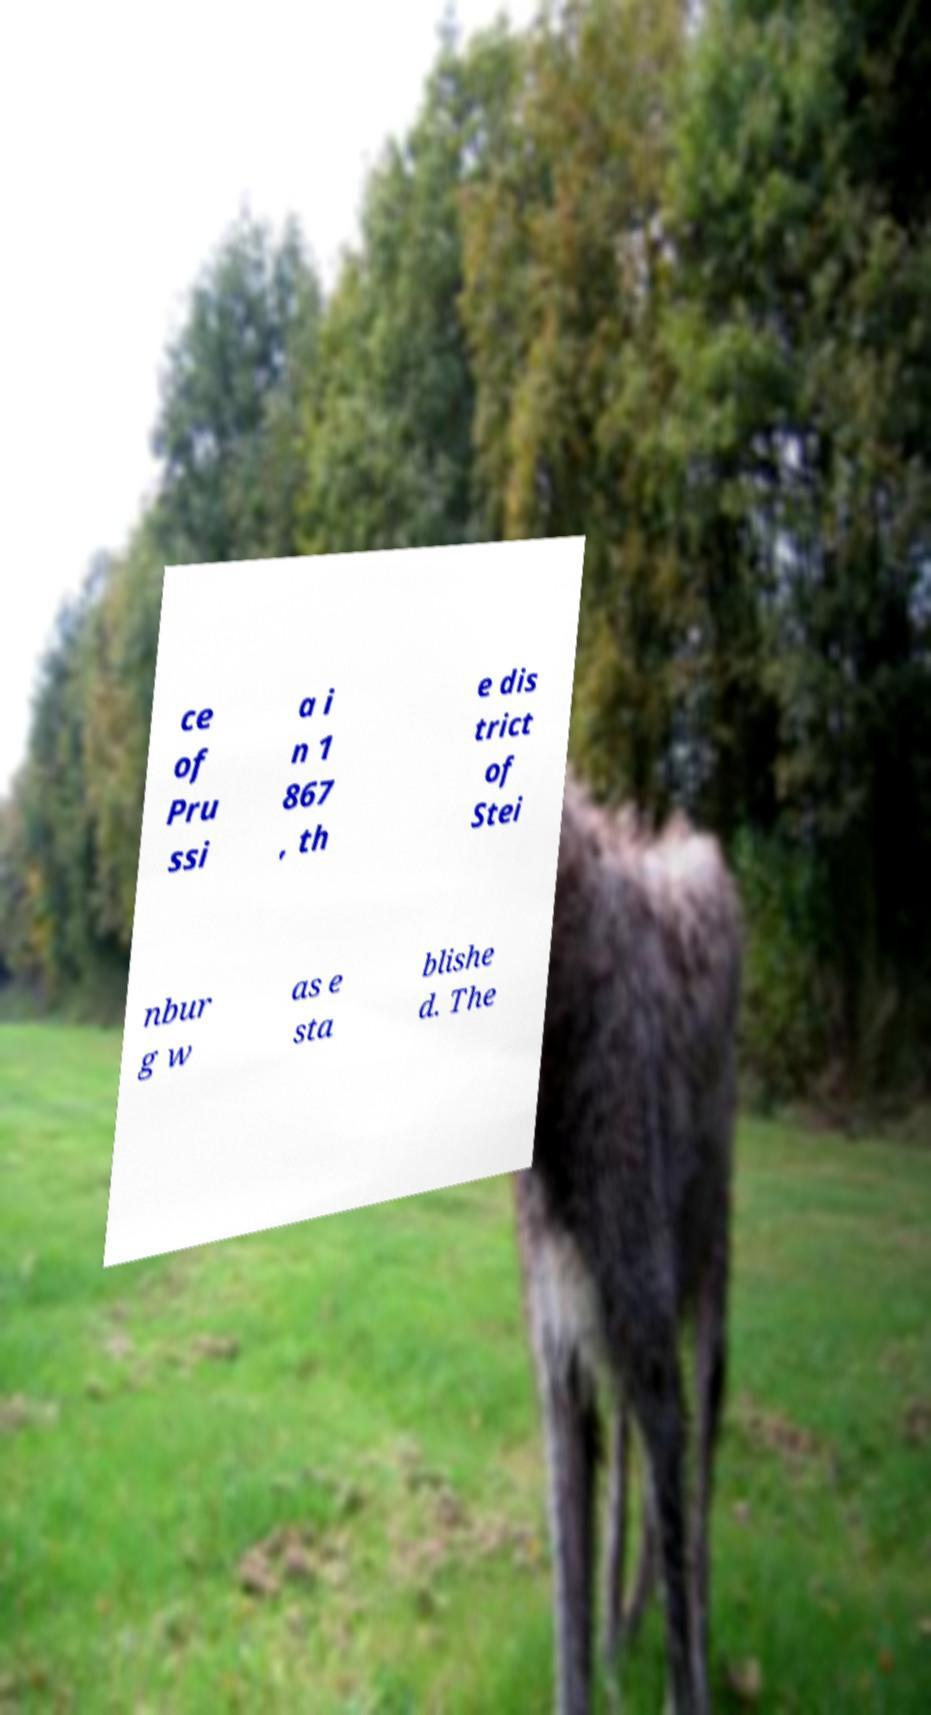Could you extract and type out the text from this image? ce of Pru ssi a i n 1 867 , th e dis trict of Stei nbur g w as e sta blishe d. The 